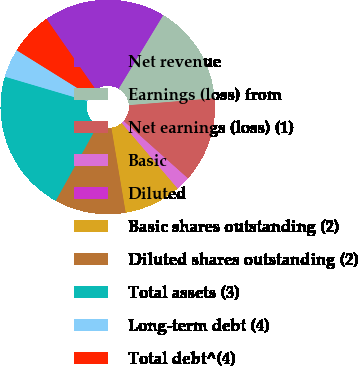Convert chart. <chart><loc_0><loc_0><loc_500><loc_500><pie_chart><fcel>Net revenue<fcel>Earnings (loss) from<fcel>Net earnings (loss) (1)<fcel>Basic<fcel>Diluted<fcel>Basic shares outstanding (2)<fcel>Diluted shares outstanding (2)<fcel>Total assets (3)<fcel>Long-term debt (4)<fcel>Total debt^(4)<nl><fcel>18.35%<fcel>15.04%<fcel>12.89%<fcel>2.15%<fcel>0.0%<fcel>8.59%<fcel>10.74%<fcel>21.49%<fcel>4.3%<fcel>6.45%<nl></chart> 